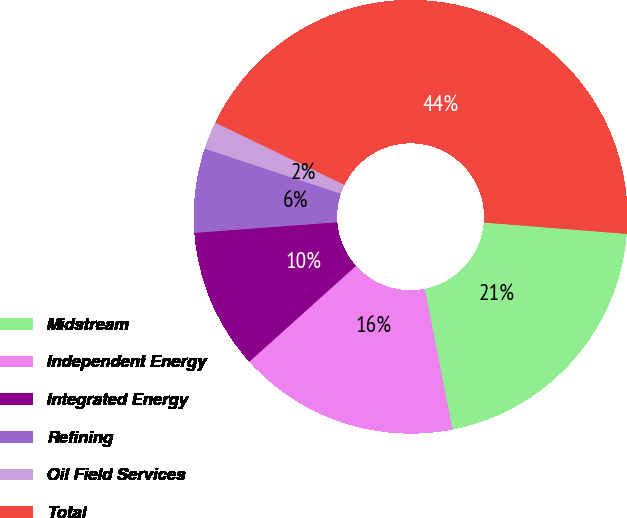Convert chart to OTSL. <chart><loc_0><loc_0><loc_500><loc_500><pie_chart><fcel>Midstream<fcel>Independent Energy<fcel>Integrated Energy<fcel>Refining<fcel>Oil Field Services<fcel>Total<nl><fcel>20.65%<fcel>16.44%<fcel>10.47%<fcel>6.27%<fcel>2.06%<fcel>44.11%<nl></chart> 